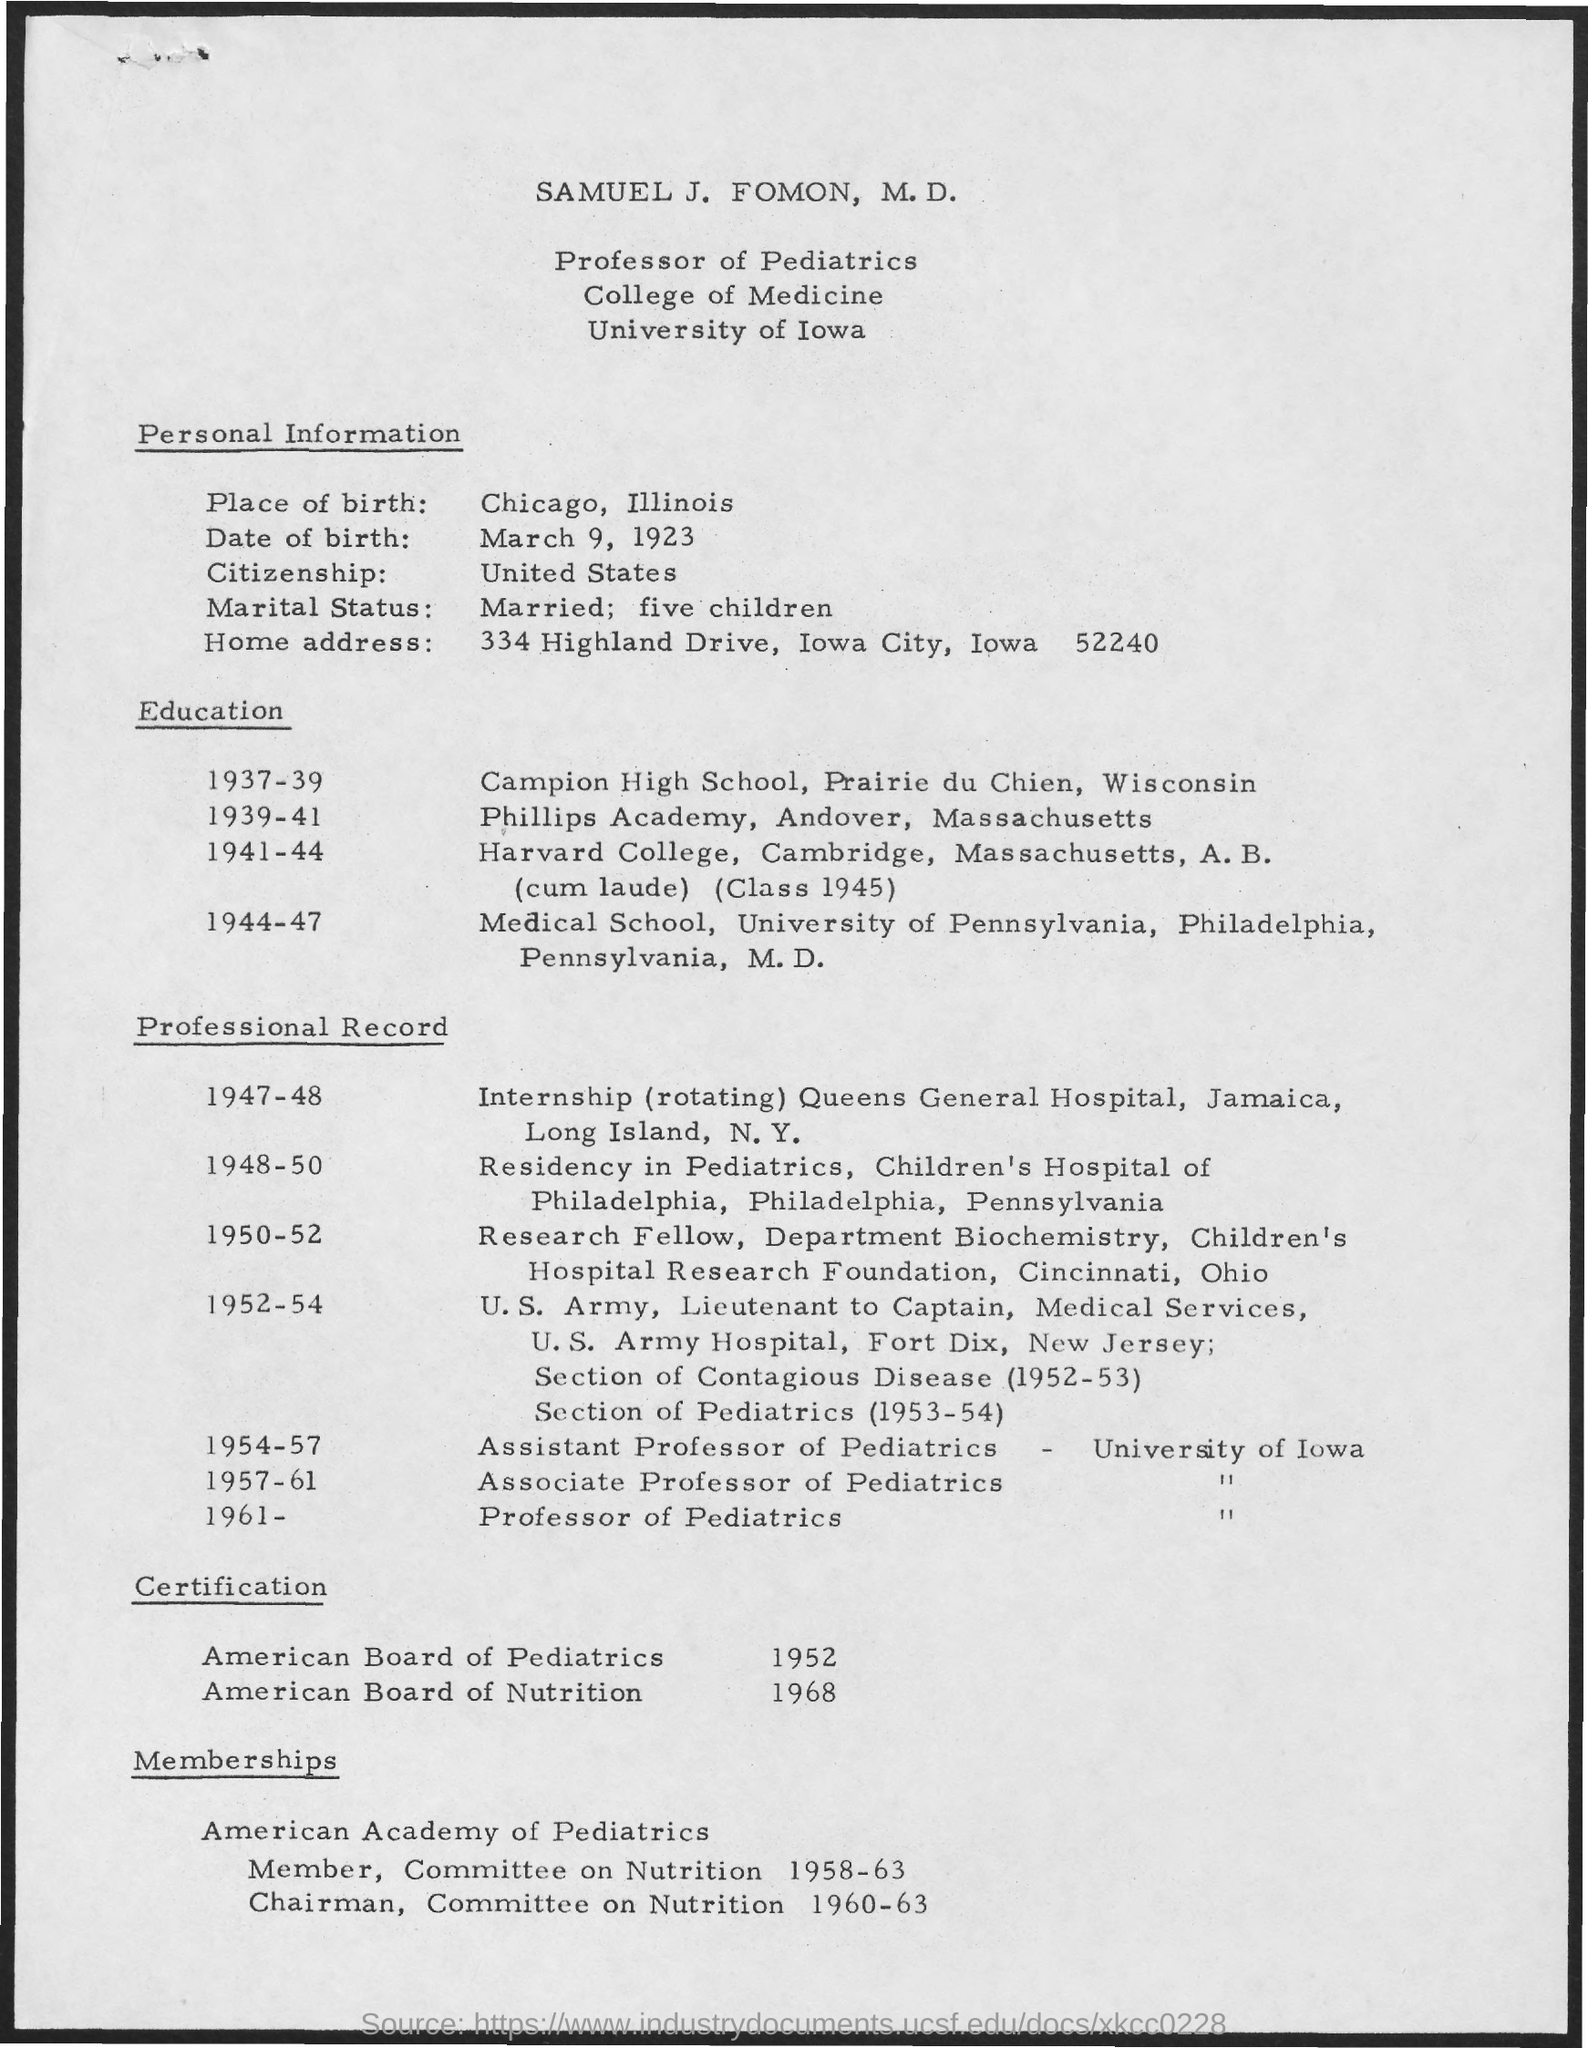What is the place of birth
Provide a succinct answer. Chicago , Illinois. What is the date of birth ?
Provide a succinct answer. March 9, 1923. In which country he has the citizenship
Give a very brief answer. United States. For which year he was the chairman of committee on nutrition ?
Offer a very short reply. 1960-63. For which year he was the member  of committee on nutrition
Ensure brevity in your answer.  1958-63. In which year he has the certification in american board of pediatrics
Offer a terse response. 1952. In which year he has the certification in american board of nutrition
Provide a succinct answer. 1968. 